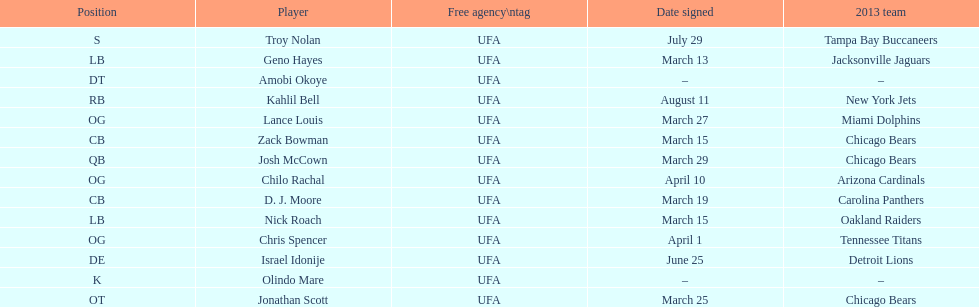The top played position according to this chart. OG. 